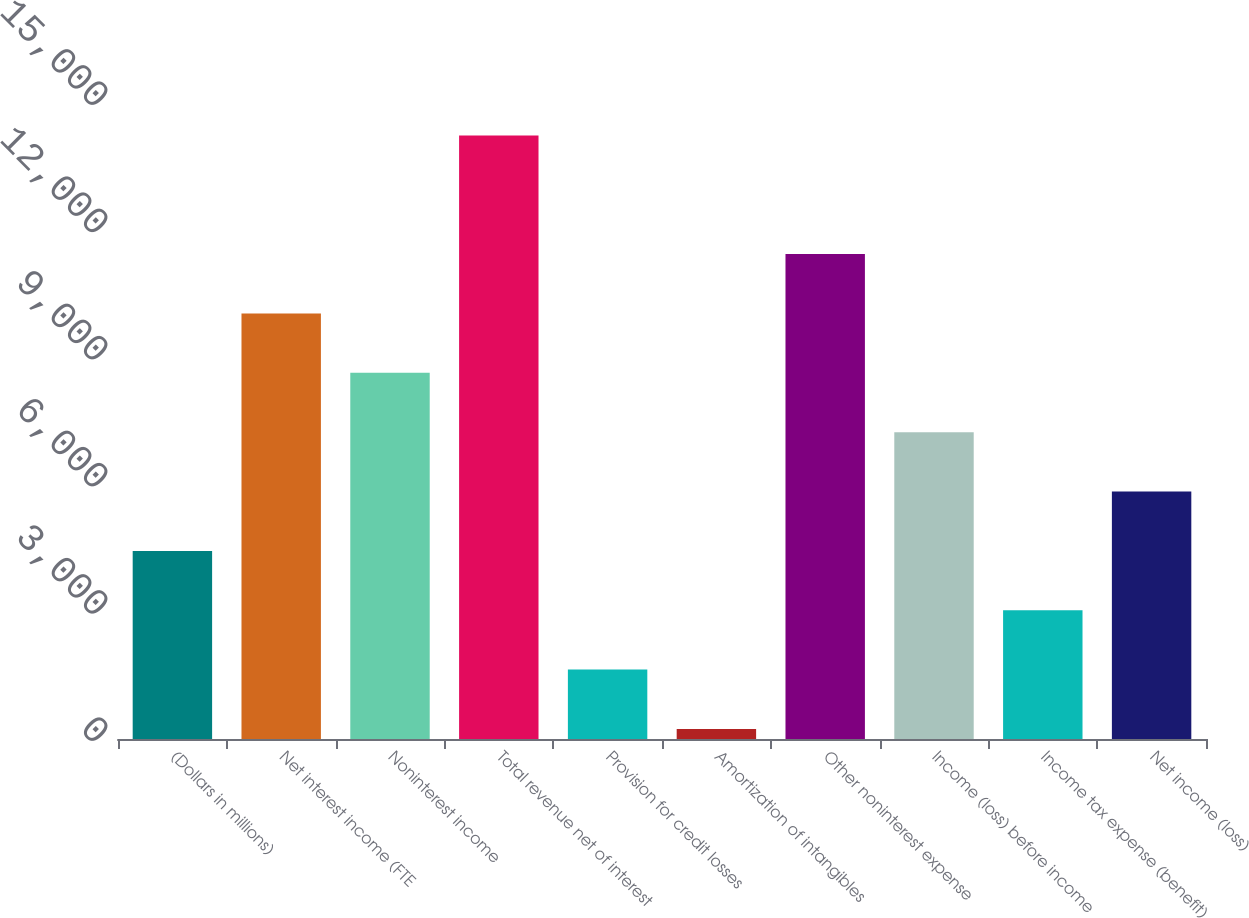<chart> <loc_0><loc_0><loc_500><loc_500><bar_chart><fcel>(Dollars in millions)<fcel>Net interest income (FTE<fcel>Noninterest income<fcel>Total revenue net of interest<fcel>Provision for credit losses<fcel>Amortization of intangibles<fcel>Other noninterest expense<fcel>Income (loss) before income<fcel>Income tax expense (benefit)<fcel>Net income (loss)<nl><fcel>4436.7<fcel>10036.3<fcel>8636.4<fcel>14236<fcel>1636.9<fcel>237<fcel>11436.2<fcel>7236.5<fcel>3036.8<fcel>5836.6<nl></chart> 